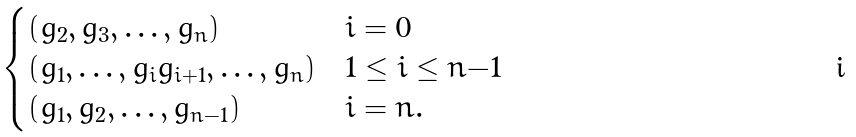<formula> <loc_0><loc_0><loc_500><loc_500>\begin{cases} ( g _ { 2 } , g _ { 3 } , \dots , g _ { n } ) & i = 0 \\ ( g _ { 1 } , \dots , g _ { i } g _ { i + 1 } , \dots , g _ { n } ) & 1 \leq i \leq n { - } 1 \\ ( g _ { 1 } , g _ { 2 } , \dots , g _ { n - 1 } ) & i = n . \end{cases}</formula> 